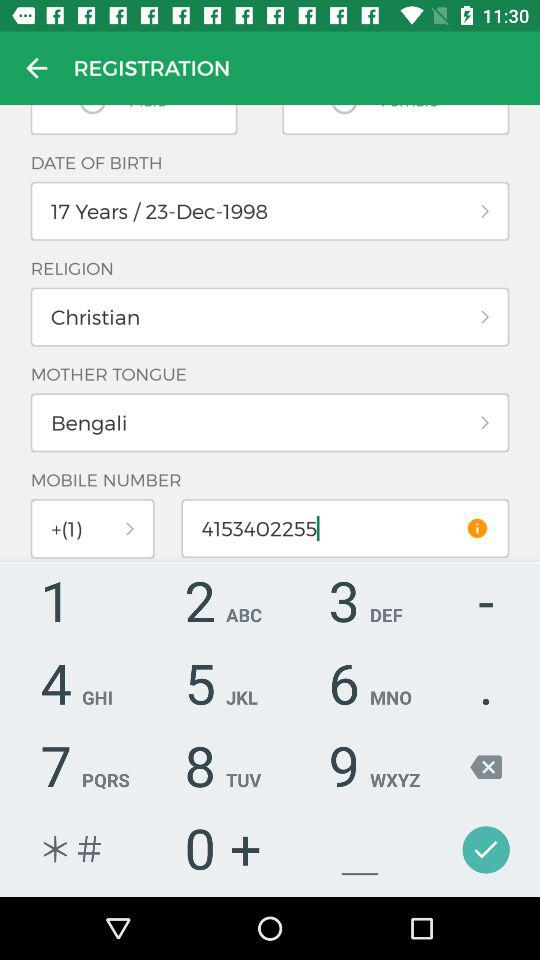What application is asking for permission? The application is "BharatMatrimony Android App". 